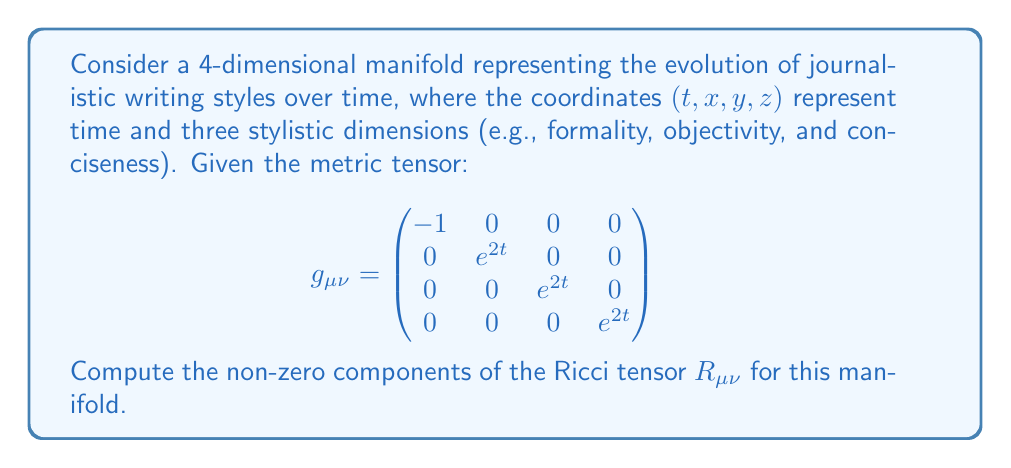Could you help me with this problem? To compute the Ricci tensor, we'll follow these steps:

1) First, we need to calculate the Christoffel symbols $\Gamma^{\lambda}_{\mu\nu}$ using the metric tensor:

   $$\Gamma^{\lambda}_{\mu\nu} = \frac{1}{2}g^{\lambda\sigma}(\partial_{\mu}g_{\nu\sigma} + \partial_{\nu}g_{\mu\sigma} - \partial_{\sigma}g_{\mu\nu})$$

2) The non-zero Christoffel symbols are:
   
   $$\Gamma^{i}_{ti} = \Gamma^{i}_{it} = 1 \quad \text{for } i = 1, 2, 3$$

3) Next, we calculate the Riemann curvature tensor:

   $$R^{\rho}_{\sigma\mu\nu} = \partial_{\mu}\Gamma^{\rho}_{\nu\sigma} - \partial_{\nu}\Gamma^{\rho}_{\mu\sigma} + \Gamma^{\rho}_{\mu\lambda}\Gamma^{\lambda}_{\nu\sigma} - \Gamma^{\rho}_{\nu\lambda}\Gamma^{\lambda}_{\mu\sigma}$$

4) The non-zero components of the Riemann tensor are:

   $$R^{i}_{tit} = -1 \quad \text{for } i = 1, 2, 3$$

5) The Ricci tensor is the contraction of the Riemann tensor:

   $$R_{\mu\nu} = R^{\lambda}_{\mu\lambda\nu}$$

6) Computing the non-zero components:

   $$R_{tt} = R^{i}_{tit} = -1 - 1 - 1 = -3$$
   
   $$R_{ii} = R^{t}_{iti} = -e^{-2t} \quad \text{for } i = 1, 2, 3$$

Therefore, the non-zero components of the Ricci tensor are:

$$R_{tt} = -3$$
$$R_{11} = R_{22} = R_{33} = -e^{-2t}$$
Answer: $R_{tt} = -3$, $R_{11} = R_{22} = R_{33} = -e^{-2t}$ 